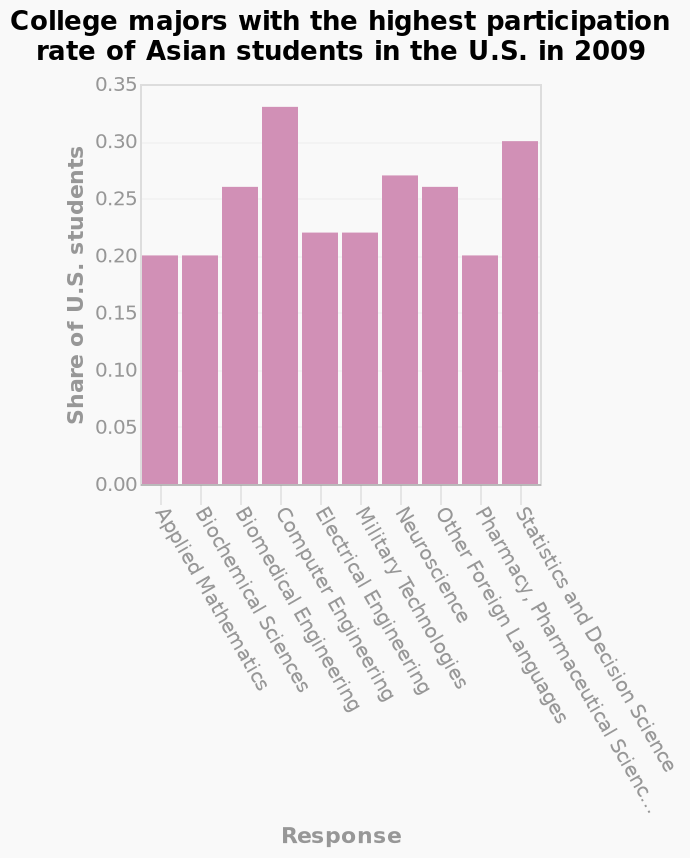<image>
What is the second most popular subject?  The second most popular subject is statistics and decision science. Which subject is more popular, computer engineering or statistics and decision science?  Computer engineering is more popular than statistics and decision science. please enumerates aspects of the construction of the chart Here a is a bar plot named College majors with the highest participation rate of Asian students in the U.S. in 2009. The y-axis plots Share of U.S. students while the x-axis plots Response. 